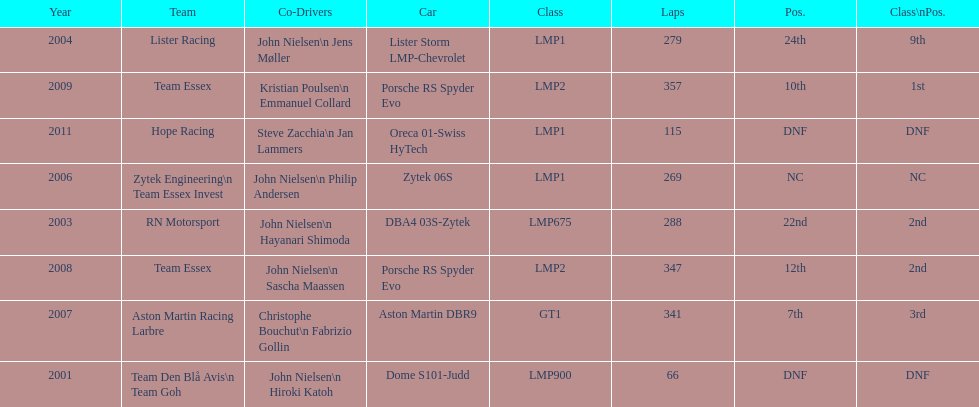What model car was the most used? Porsche RS Spyder. 